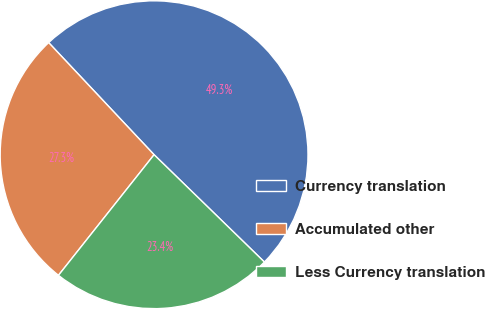Convert chart to OTSL. <chart><loc_0><loc_0><loc_500><loc_500><pie_chart><fcel>Currency translation<fcel>Accumulated other<fcel>Less Currency translation<nl><fcel>49.29%<fcel>27.32%<fcel>23.39%<nl></chart> 